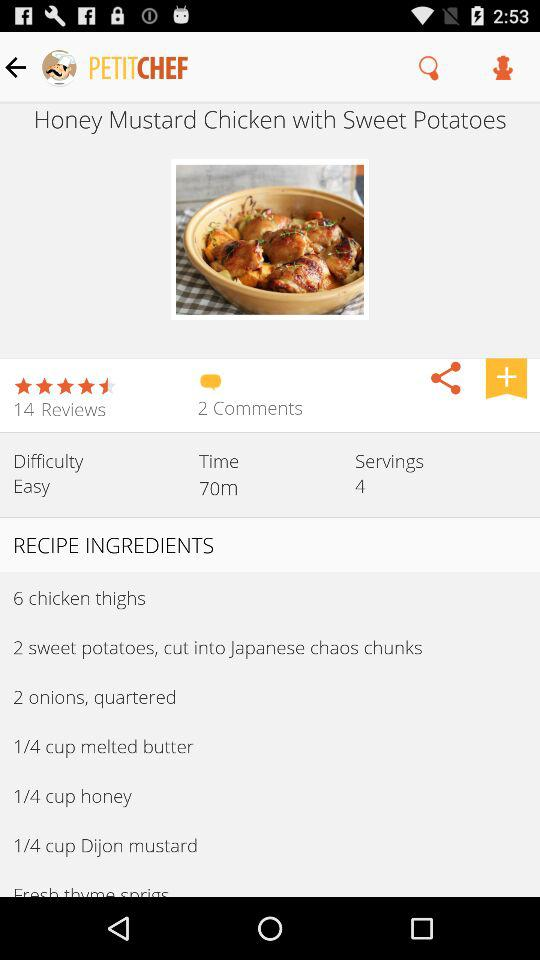How many servings does this recipe make?
Answer the question using a single word or phrase. 4 